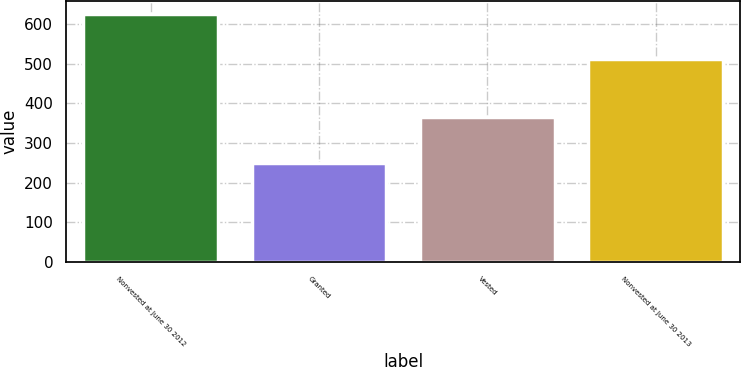<chart> <loc_0><loc_0><loc_500><loc_500><bar_chart><fcel>Nonvested at June 30 2012<fcel>Granted<fcel>Vested<fcel>Nonvested at June 30 2013<nl><fcel>625.9<fcel>250.9<fcel>365.9<fcel>510.9<nl></chart> 